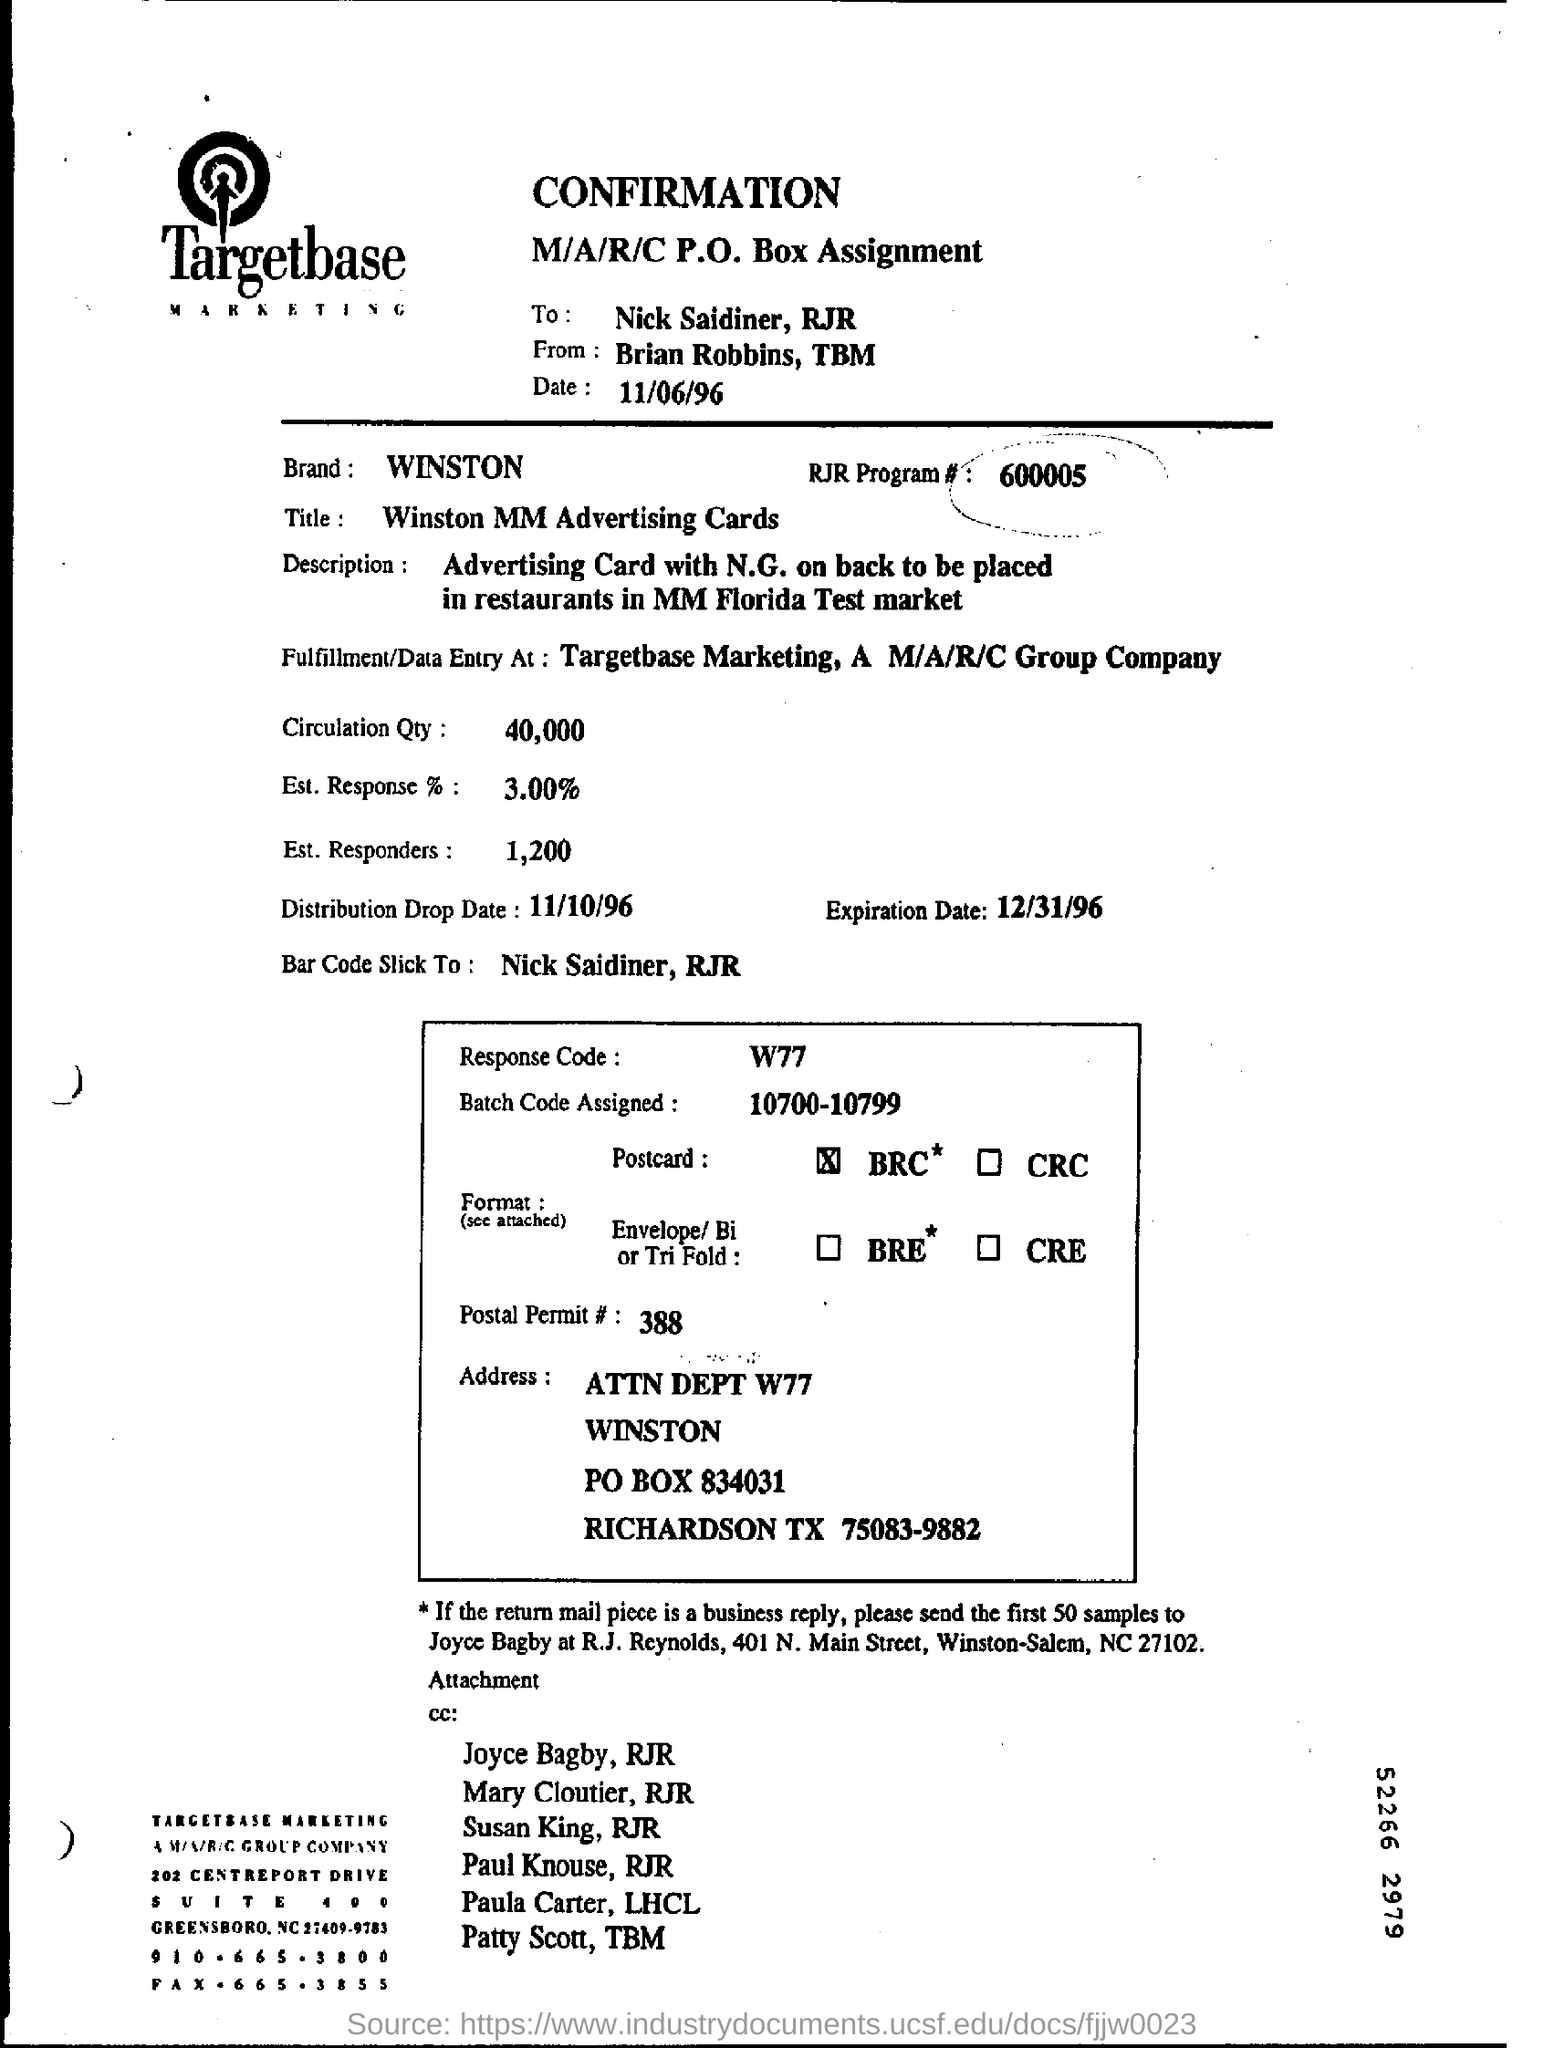Draw attention to some important aspects in this diagram. The expiration date mentioned is December 31, 1996. The batch code assigned is within the range of 10,700 to 10,799. The response code given is W77.. 